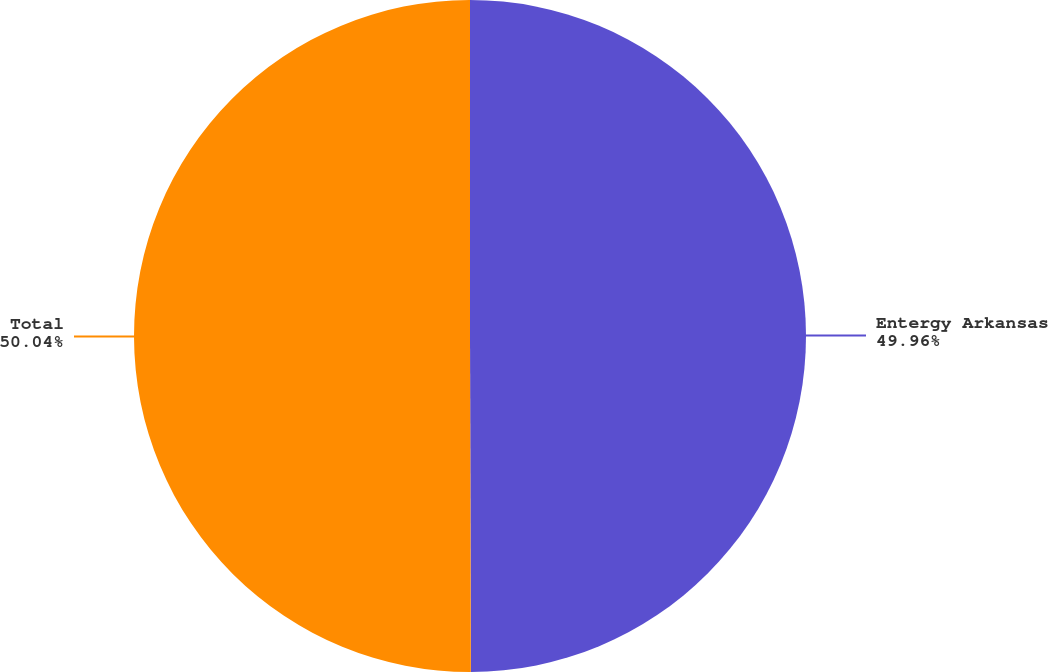<chart> <loc_0><loc_0><loc_500><loc_500><pie_chart><fcel>Entergy Arkansas<fcel>Total<nl><fcel>49.96%<fcel>50.04%<nl></chart> 